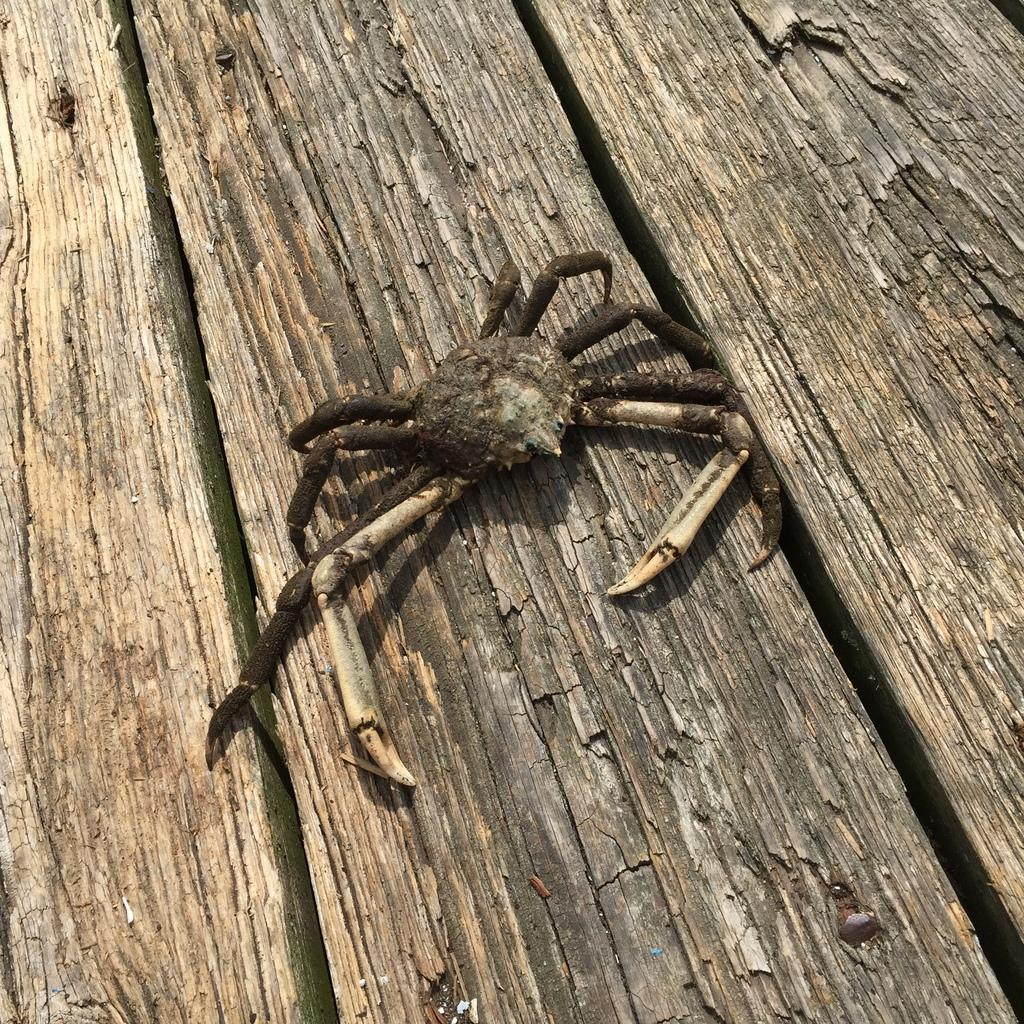What is the main subject of the picture? The main subject of the picture is a crab. Can you describe the surface the crab is on? The crab is on a wooden surface. How many clams are visible in the image? There are no clams present in the image; it features a crab on a wooden surface. What type of angle is the crab positioned at in the image? The image does not provide information about the angle at which the crab is positioned. 